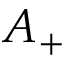<formula> <loc_0><loc_0><loc_500><loc_500>A _ { + }</formula> 